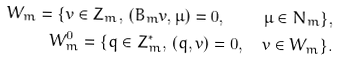Convert formula to latex. <formula><loc_0><loc_0><loc_500><loc_500>W _ { m } = \{ v \in Z _ { m } , \, ( B _ { m } v , \mu ) = 0 , \quad \mu \in N _ { m } \} , \\ W _ { m } ^ { 0 } = \{ q \in Z _ { m } ^ { * } , \, ( q , v ) = 0 , \quad v \in W _ { m } \} .</formula> 